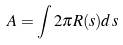<formula> <loc_0><loc_0><loc_500><loc_500>A = \int 2 \pi R ( s ) d s</formula> 